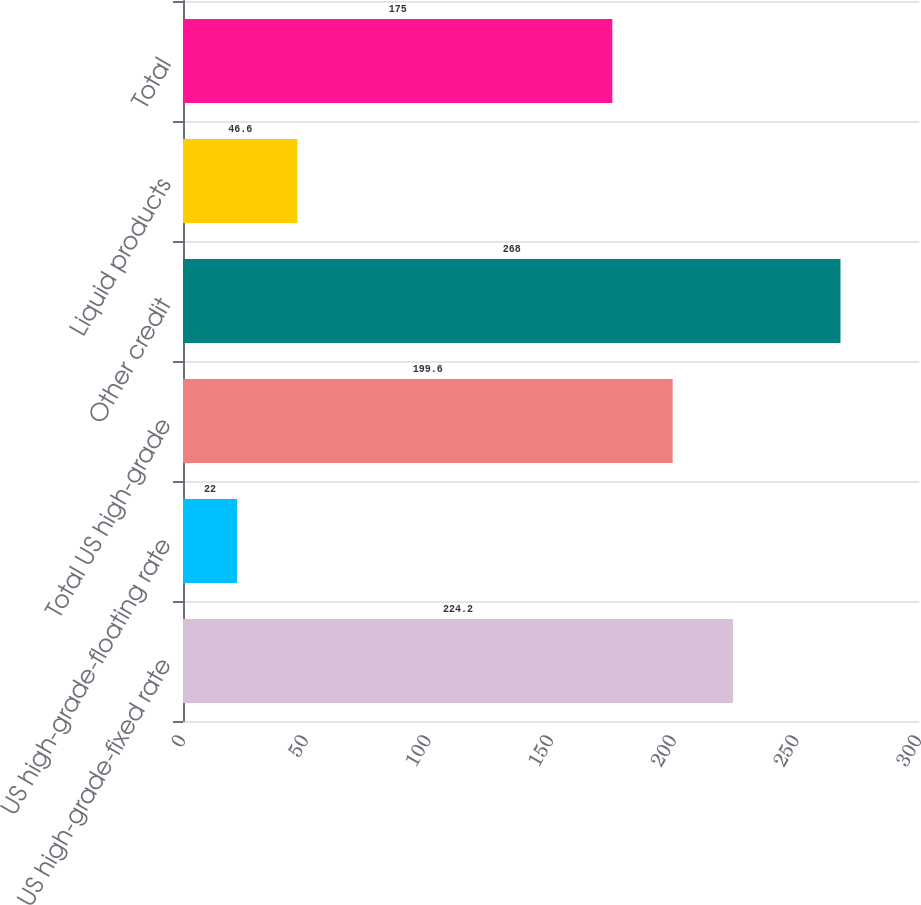Convert chart. <chart><loc_0><loc_0><loc_500><loc_500><bar_chart><fcel>US high-grade-fixed rate<fcel>US high-grade-floating rate<fcel>Total US high-grade<fcel>Other credit<fcel>Liquid products<fcel>Total<nl><fcel>224.2<fcel>22<fcel>199.6<fcel>268<fcel>46.6<fcel>175<nl></chart> 